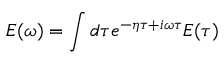Convert formula to latex. <formula><loc_0><loc_0><loc_500><loc_500>E ( \omega ) = \int d \tau e ^ { - \eta \tau + i \omega \tau } E ( \tau )</formula> 